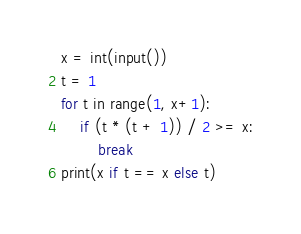Convert code to text. <code><loc_0><loc_0><loc_500><loc_500><_Python_>x = int(input())
t = 1
for t in range(1, x+1):
    if (t * (t + 1)) / 2 >= x:
        break
print(x if t == x else t)
</code> 